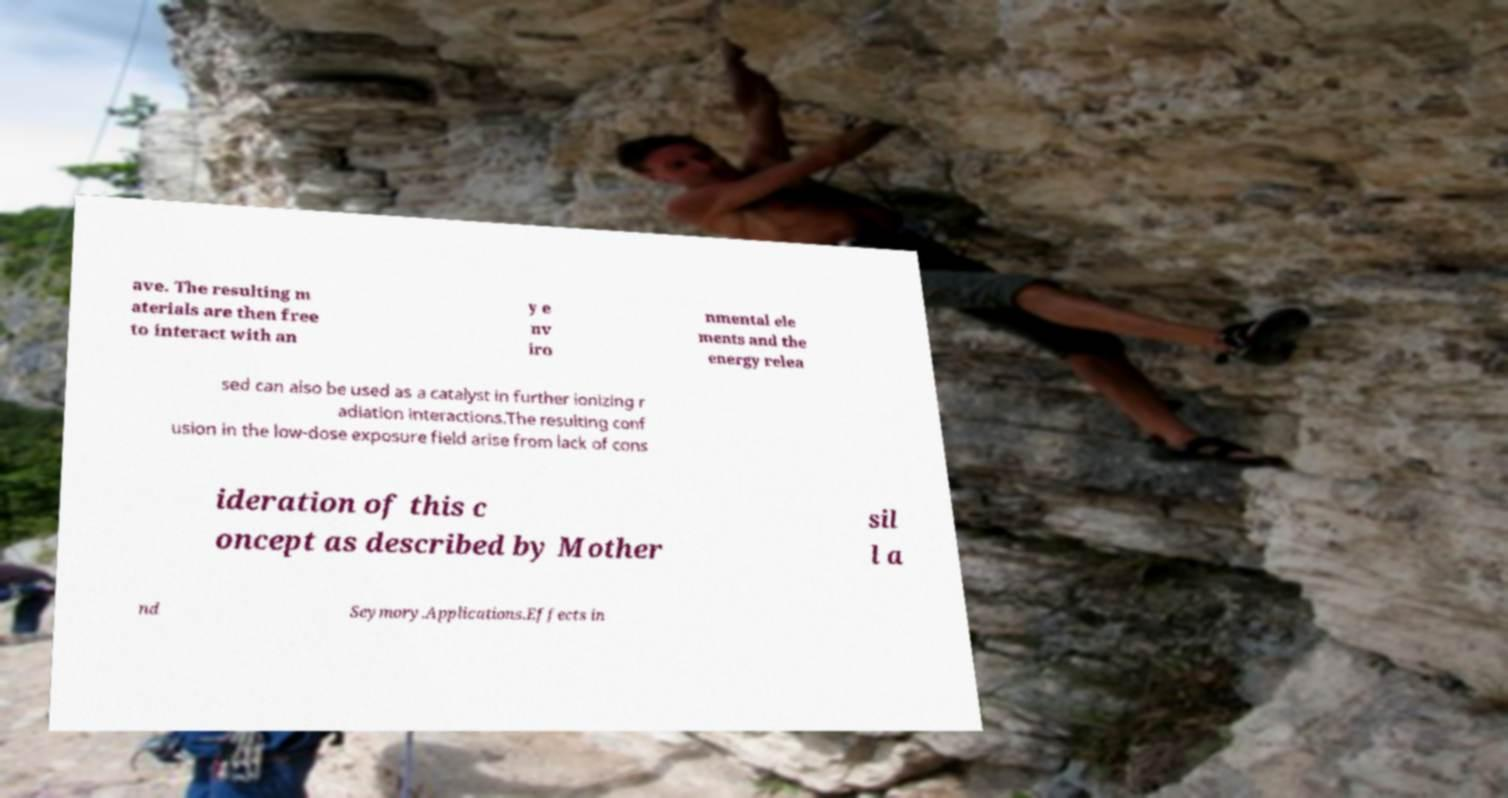There's text embedded in this image that I need extracted. Can you transcribe it verbatim? ave. The resulting m aterials are then free to interact with an y e nv iro nmental ele ments and the energy relea sed can also be used as a catalyst in further ionizing r adiation interactions.The resulting conf usion in the low-dose exposure field arise from lack of cons ideration of this c oncept as described by Mother sil l a nd Seymory.Applications.Effects in 